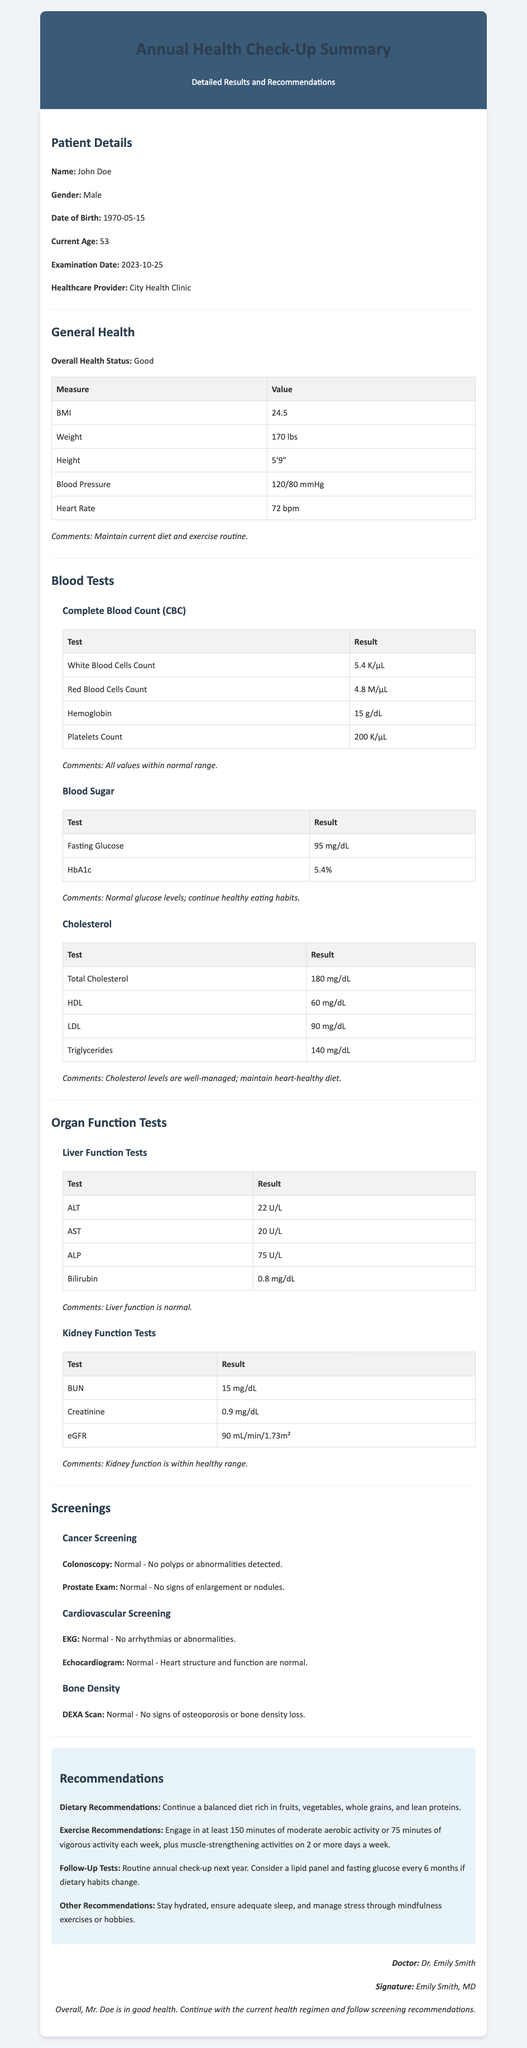What is the patient's name? The patient's name is mentioned in the Patient Details section.
Answer: John Doe What is the patient's BMI? The BMI value is listed under General Health.
Answer: 24.5 What is the result of the Fasting Glucose test? The Fasting Glucose result is found in the Blood Sugar subsection.
Answer: 95 mg/dL When was the examination date? The examination date is noted in the Patient Details section.
Answer: 2023-10-25 What is the recommendation for exercise? The exercise recommendation is provided in the Recommendations section.
Answer: 150 minutes of moderate aerobic activity What is the total cholesterol level? The total cholesterol level is found in the Cholesterol subsection.
Answer: 180 mg/dL What is the result of the Kidney Function Tests eGFR? The eGFR result can be found in the Kidney Function Tests subsection.
Answer: 90 mL/min/1.73m² Was there any sign of osteoporosis according to the DEXA Scan? This information is located in the Bone Density section.
Answer: No signs of osteoporosis What comments were made regarding the kidney function? The comments on kidney function are located under the Kidney Function Tests subsection.
Answer: Kidney function is within healthy range 